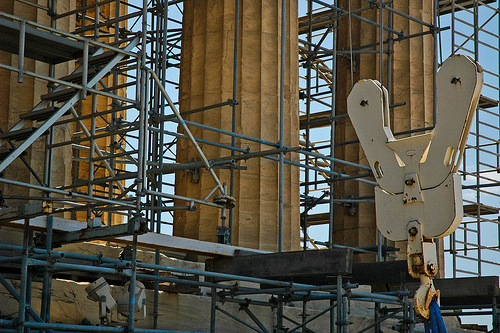<image>
Can you confirm if the lift is above the hook? Yes. The lift is positioned above the hook in the vertical space, higher up in the scene. 